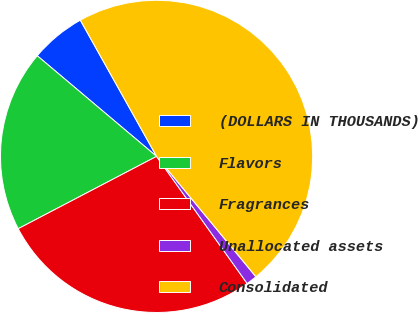Convert chart. <chart><loc_0><loc_0><loc_500><loc_500><pie_chart><fcel>(DOLLARS IN THOUSANDS)<fcel>Flavors<fcel>Fragrances<fcel>Unallocated assets<fcel>Consolidated<nl><fcel>5.73%<fcel>18.82%<fcel>27.19%<fcel>1.13%<fcel>47.14%<nl></chart> 